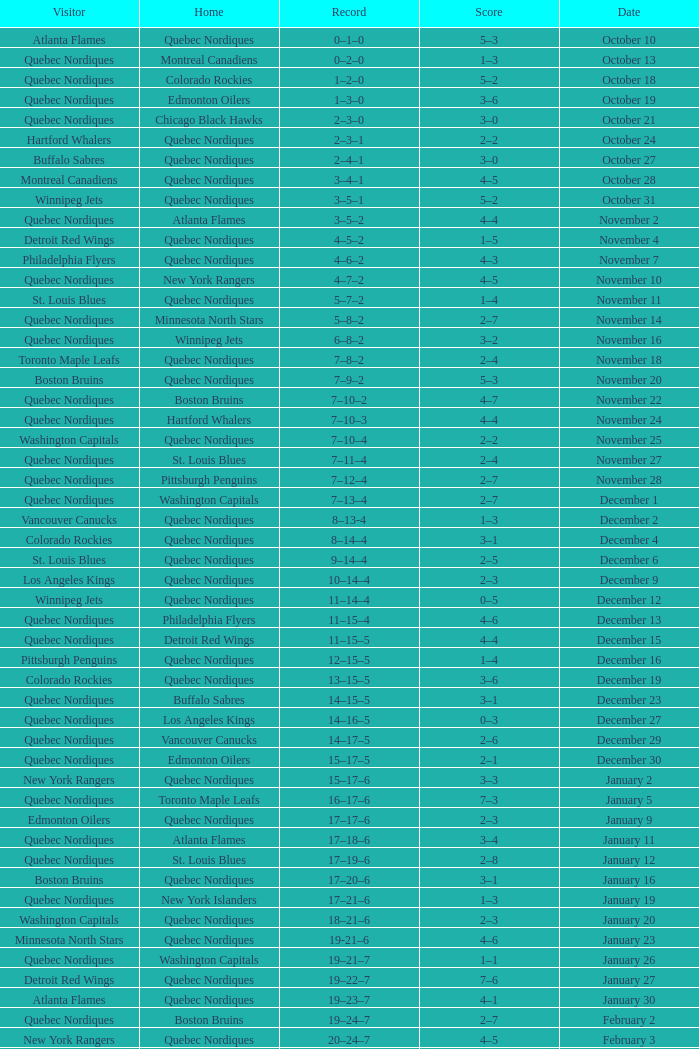Which Home has a Record of 16–17–6? Toronto Maple Leafs. 